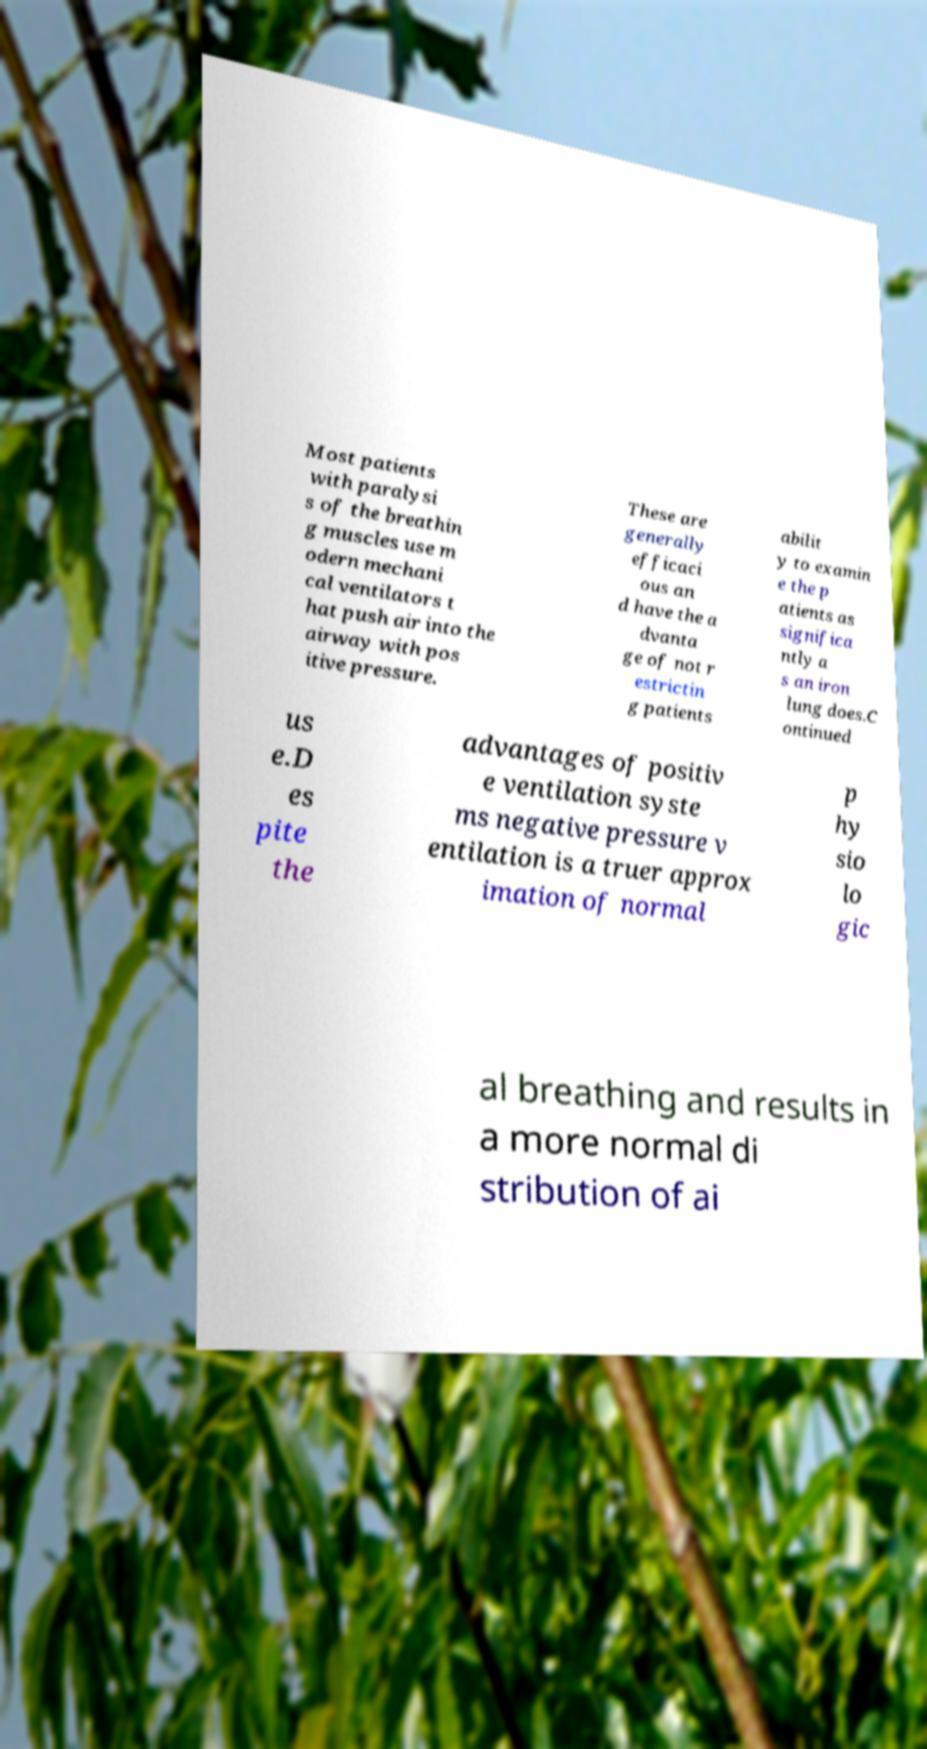What messages or text are displayed in this image? I need them in a readable, typed format. Most patients with paralysi s of the breathin g muscles use m odern mechani cal ventilators t hat push air into the airway with pos itive pressure. These are generally efficaci ous an d have the a dvanta ge of not r estrictin g patients abilit y to examin e the p atients as significa ntly a s an iron lung does.C ontinued us e.D es pite the advantages of positiv e ventilation syste ms negative pressure v entilation is a truer approx imation of normal p hy sio lo gic al breathing and results in a more normal di stribution of ai 